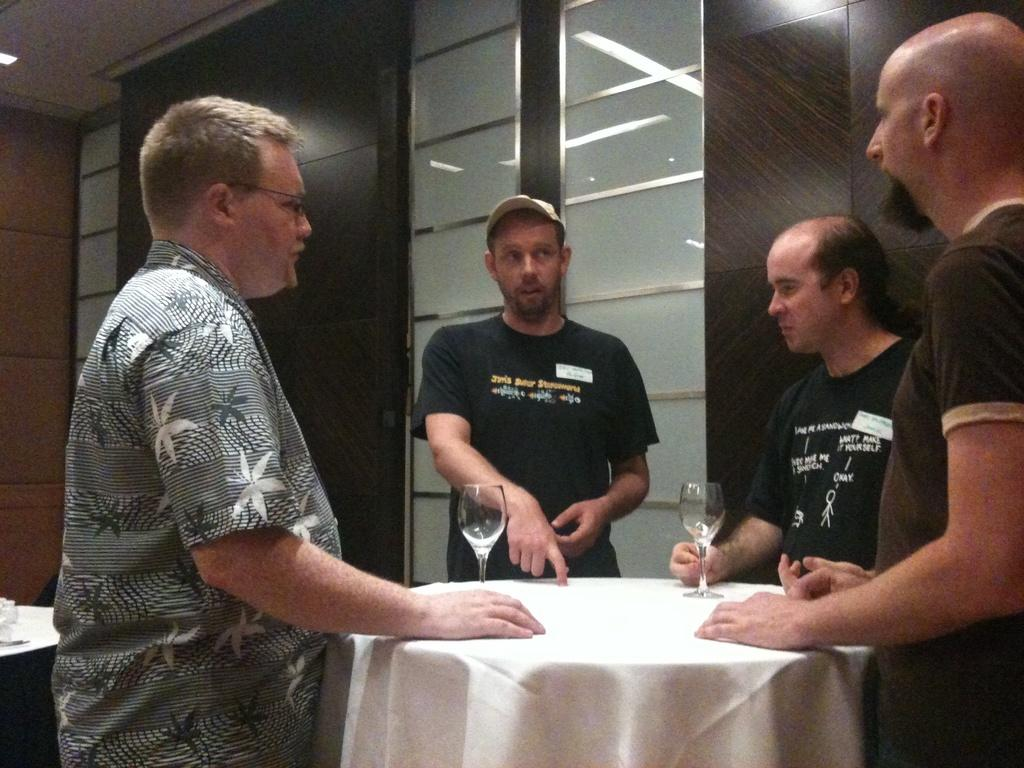Who is present in the image? There are men in the image. What are the men doing in the image? The men are standing in front of a table. What objects can be seen on the table? There are cups on the table. What flavor of ice cream is being served by the governor in the image? There is no ice cream or governor present in the image. 